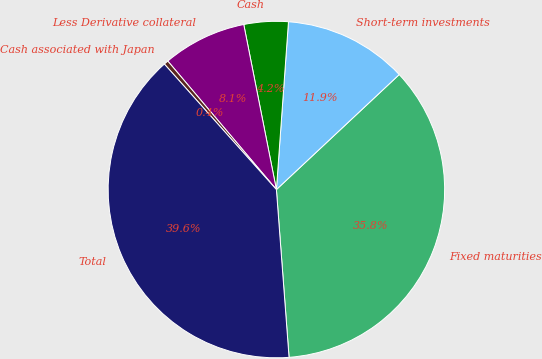<chart> <loc_0><loc_0><loc_500><loc_500><pie_chart><fcel>Fixed maturities<fcel>Short-term investments<fcel>Cash<fcel>Less Derivative collateral<fcel>Cash associated with Japan<fcel>Total<nl><fcel>35.78%<fcel>11.88%<fcel>4.25%<fcel>8.06%<fcel>0.43%<fcel>39.6%<nl></chart> 